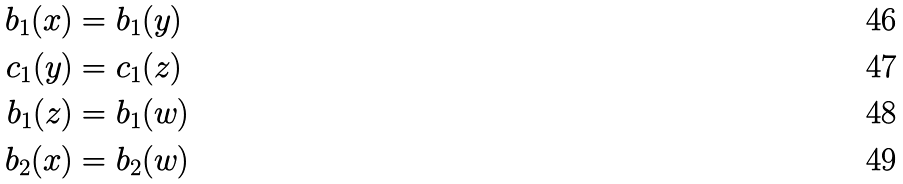Convert formula to latex. <formula><loc_0><loc_0><loc_500><loc_500>b _ { 1 } ( x ) & = b _ { 1 } ( y ) \\ c _ { 1 } ( y ) & = c _ { 1 } ( z ) \\ b _ { 1 } ( z ) & = b _ { 1 } ( w ) \\ b _ { 2 } ( x ) & = b _ { 2 } ( w )</formula> 